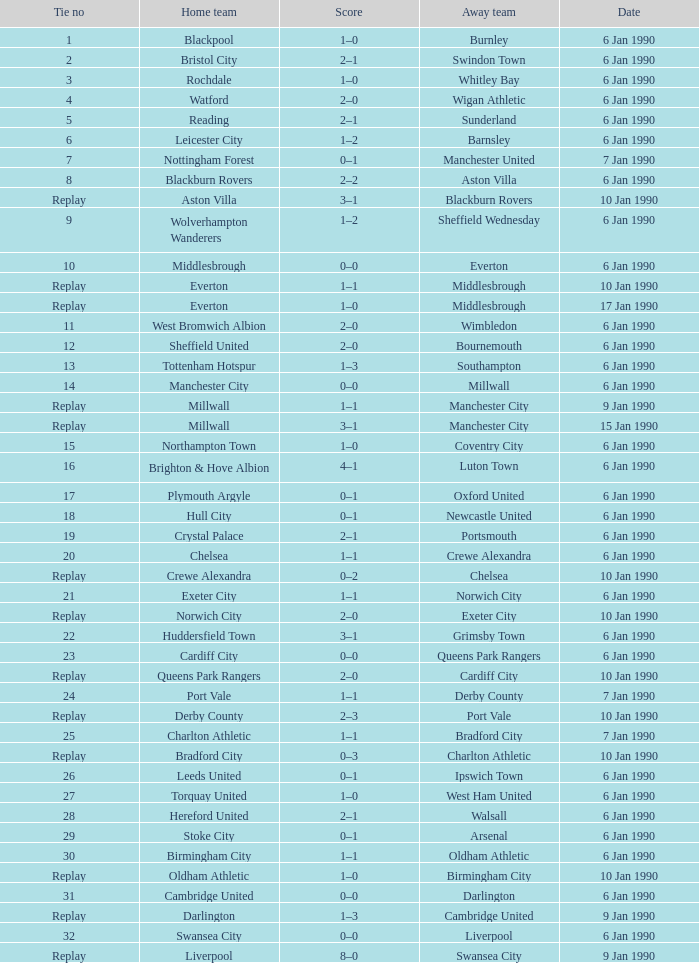What was the final score of the match against the visiting team, crewe alexandra? 1–1. 